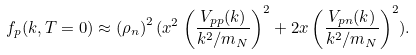Convert formula to latex. <formula><loc_0><loc_0><loc_500><loc_500>f _ { p } ( k , T = 0 ) \approx \left ( { \rho _ { n } } \right ) ^ { 2 } ( x ^ { 2 } \left ( \frac { V _ { p p } ( k ) } { k ^ { 2 } / m _ { N } } \right ) ^ { 2 } + 2 x \left ( \frac { V _ { p n } ( k ) } { k ^ { 2 } / m _ { N } } \right ) ^ { 2 } ) .</formula> 